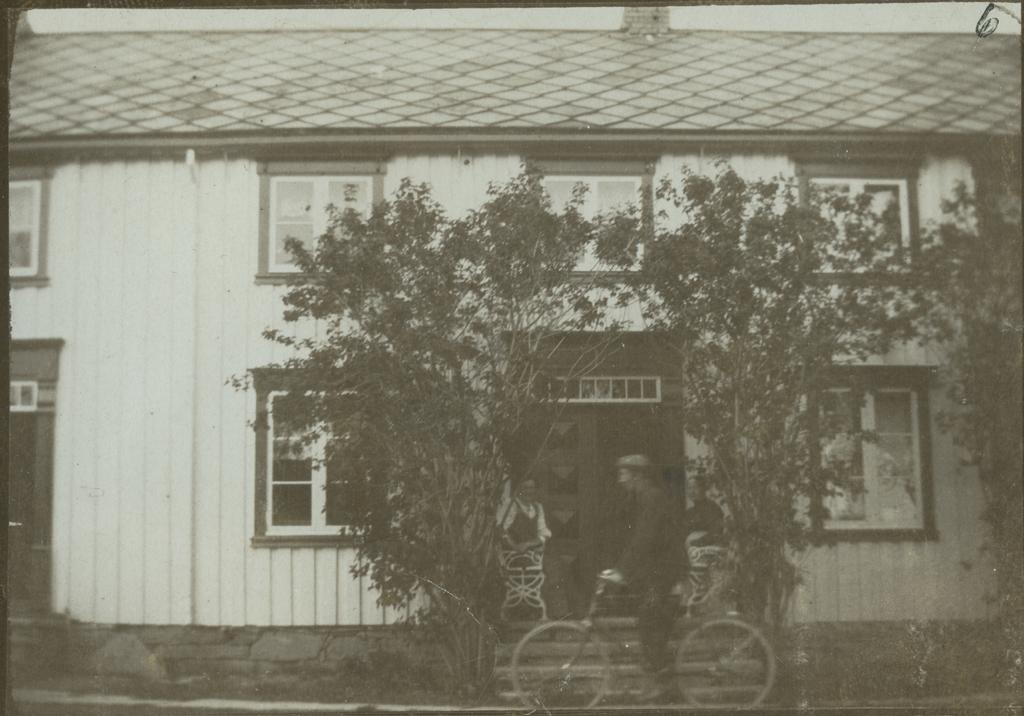What type of structure is present in the image? There is a building in the image. What can be seen in the background of the image? There are trees in the image. How many people are sitting in the image? Two persons are sitting in the image. What activity is one of the persons in the image engaged in? There is a person riding a cycle in the image. How many spiders are crawling on the building in the image? There are no spiders present in the image. What color is the paint used on the building in the image? The provided facts do not mention the color of the paint on the building. Can you see a chessboard in the image? There is no chessboard present in the image. 